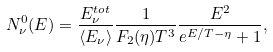<formula> <loc_0><loc_0><loc_500><loc_500>N _ { \nu } ^ { 0 } ( E ) = \frac { E _ { \nu } ^ { t o t } } { \langle E _ { \nu } \rangle } \frac { 1 } { F _ { 2 } ( \eta ) T ^ { 3 } } \frac { E ^ { 2 } } { e ^ { E / T - \eta } + 1 } ,</formula> 